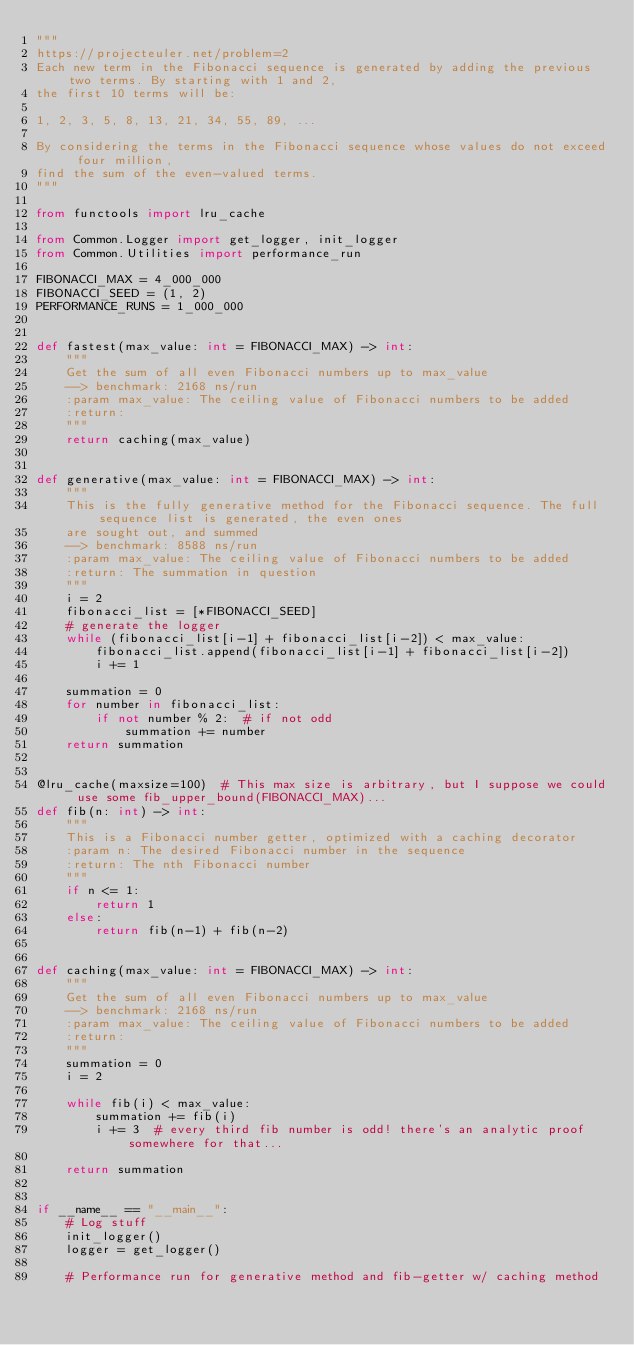Convert code to text. <code><loc_0><loc_0><loc_500><loc_500><_Python_>"""
https://projecteuler.net/problem=2
Each new term in the Fibonacci sequence is generated by adding the previous two terms. By starting with 1 and 2,
the first 10 terms will be:

1, 2, 3, 5, 8, 13, 21, 34, 55, 89, ...

By considering the terms in the Fibonacci sequence whose values do not exceed four million,
find the sum of the even-valued terms.
"""

from functools import lru_cache

from Common.Logger import get_logger, init_logger
from Common.Utilities import performance_run

FIBONACCI_MAX = 4_000_000
FIBONACCI_SEED = (1, 2)
PERFORMANCE_RUNS = 1_000_000


def fastest(max_value: int = FIBONACCI_MAX) -> int:
    """
    Get the sum of all even Fibonacci numbers up to max_value
    --> benchmark: 2168 ns/run
    :param max_value: The ceiling value of Fibonacci numbers to be added
    :return:
    """
    return caching(max_value)


def generative(max_value: int = FIBONACCI_MAX) -> int:
    """
    This is the fully generative method for the Fibonacci sequence. The full sequence list is generated, the even ones
    are sought out, and summed
    --> benchmark: 8588 ns/run
    :param max_value: The ceiling value of Fibonacci numbers to be added
    :return: The summation in question
    """
    i = 2
    fibonacci_list = [*FIBONACCI_SEED]
    # generate the logger
    while (fibonacci_list[i-1] + fibonacci_list[i-2]) < max_value:
        fibonacci_list.append(fibonacci_list[i-1] + fibonacci_list[i-2])
        i += 1

    summation = 0
    for number in fibonacci_list:
        if not number % 2:  # if not odd
            summation += number
    return summation


@lru_cache(maxsize=100)  # This max size is arbitrary, but I suppose we could use some fib_upper_bound(FIBONACCI_MAX)...
def fib(n: int) -> int:
    """
    This is a Fibonacci number getter, optimized with a caching decorator
    :param n: The desired Fibonacci number in the sequence
    :return: The nth Fibonacci number
    """
    if n <= 1:
        return 1
    else:
        return fib(n-1) + fib(n-2)


def caching(max_value: int = FIBONACCI_MAX) -> int:
    """
    Get the sum of all even Fibonacci numbers up to max_value
    --> benchmark: 2168 ns/run
    :param max_value: The ceiling value of Fibonacci numbers to be added
    :return:
    """
    summation = 0
    i = 2

    while fib(i) < max_value:
        summation += fib(i)
        i += 3  # every third fib number is odd! there's an analytic proof somewhere for that...

    return summation


if __name__ == "__main__":
    # Log stuff
    init_logger()
    logger = get_logger()

    # Performance run for generative method and fib-getter w/ caching method</code> 